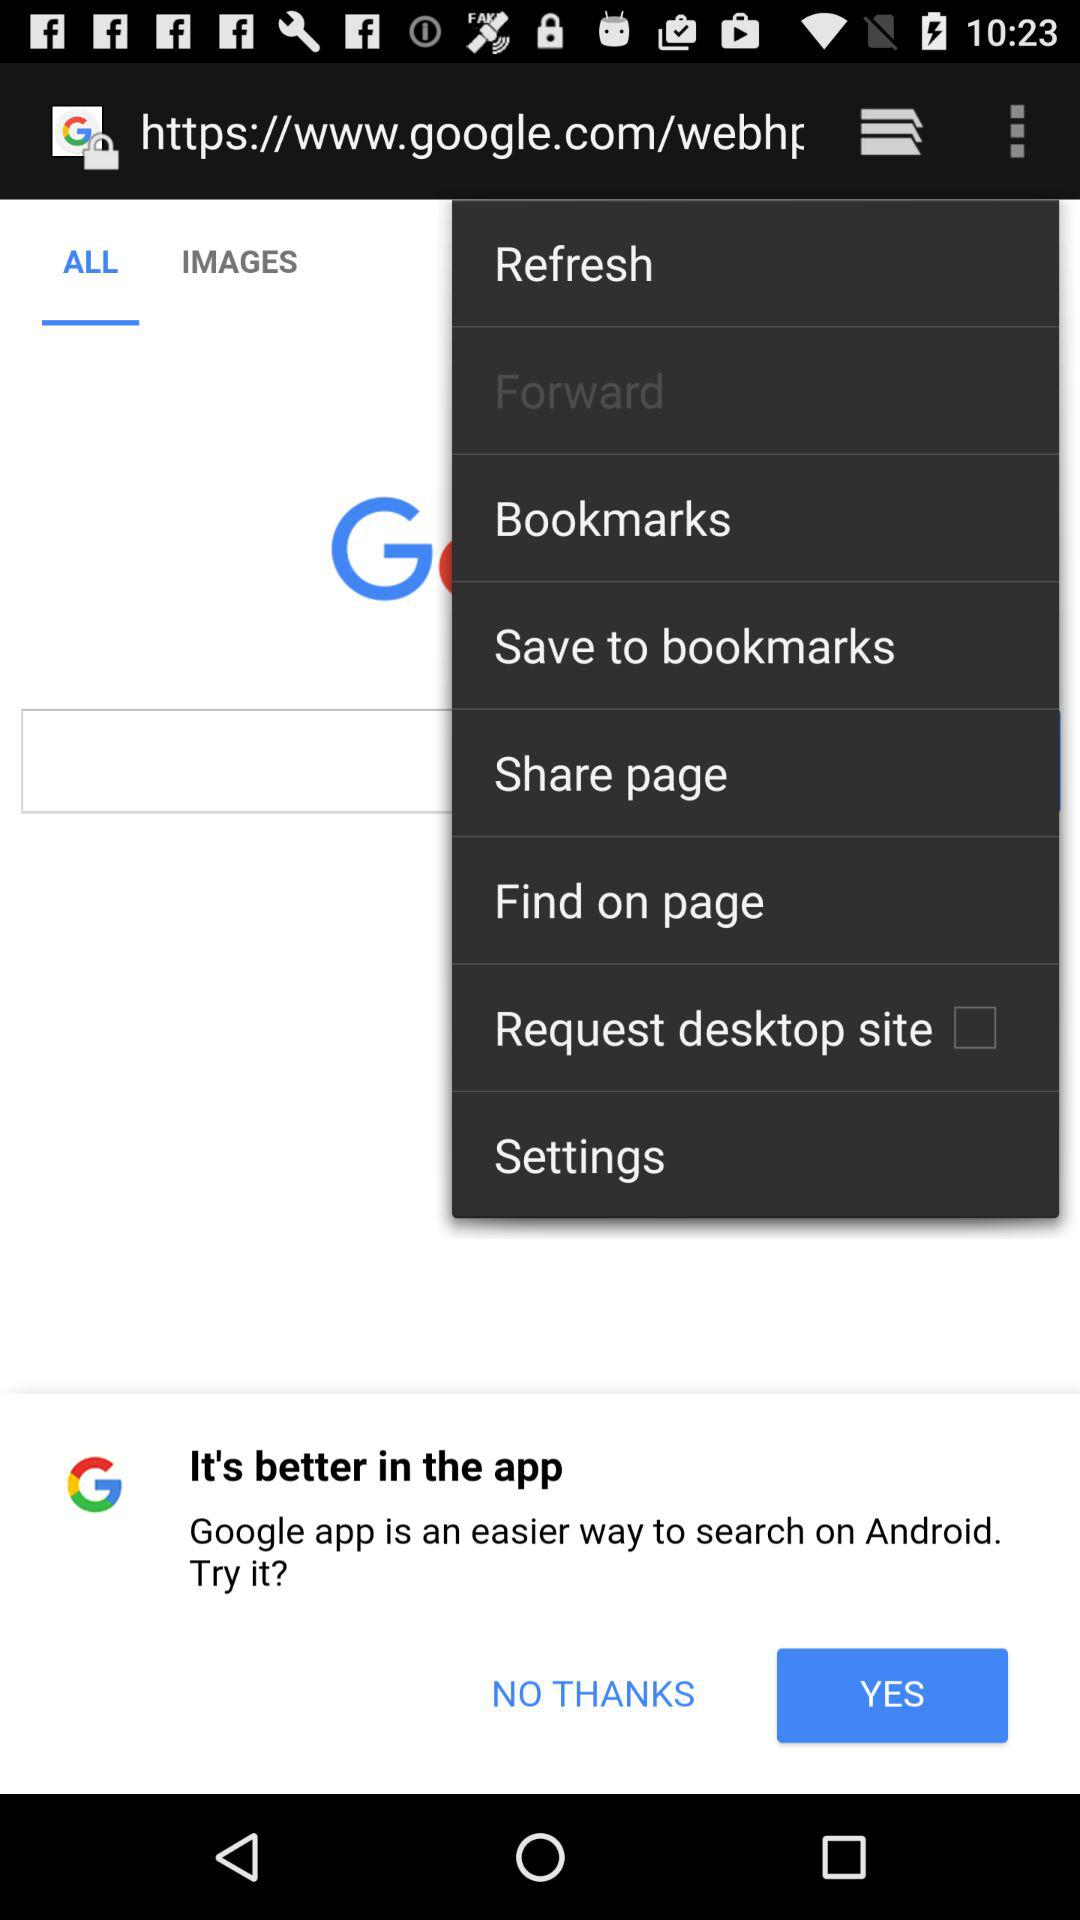What is the status of "Request desktop site"? The status is "off". 